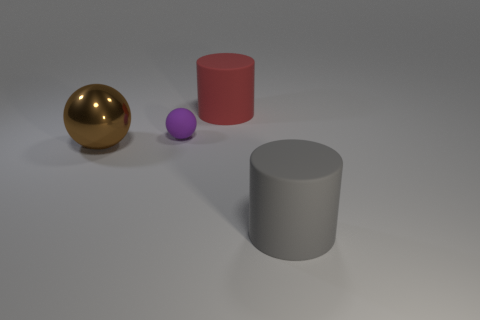Add 3 cyan matte cylinders. How many objects exist? 7 Subtract 0 blue cylinders. How many objects are left? 4 Subtract all tiny cyan rubber spheres. Subtract all tiny things. How many objects are left? 3 Add 2 red objects. How many red objects are left? 3 Add 1 purple balls. How many purple balls exist? 2 